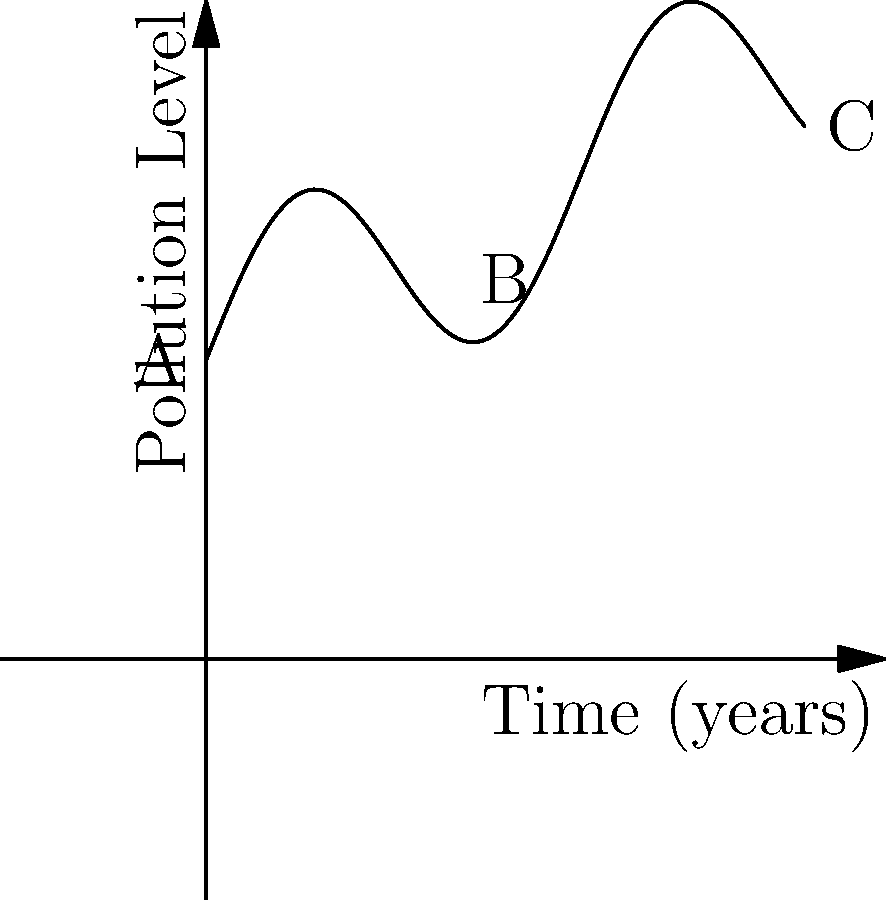The curve above represents the pollution levels in a major industrial area over a 10-year period. If $P(t)$ denotes the pollution level at time $t$, and $P(t) = 5 + 2\sin(t) + 0.5t$, calculate the rate of change in pollution levels at $t=5$ years. How does this information assist in evaluating the effectiveness of current environmental regulations? To solve this problem, we need to follow these steps:

1) The rate of change in pollution levels at any given time is represented by the derivative of $P(t)$ with respect to $t$.

2) Given: $P(t) = 5 + 2\sin(t) + 0.5t$

3) To find $\frac{dP}{dt}$, we differentiate each term:
   $\frac{d}{dt}(5) = 0$
   $\frac{d}{dt}(2\sin(t)) = 2\cos(t)$
   $\frac{d}{dt}(0.5t) = 0.5$

4) Therefore, $\frac{dP}{dt} = 2\cos(t) + 0.5$

5) At $t=5$:
   $\frac{dP}{dt}|_{t=5} = 2\cos(5) + 0.5 \approx 0.7145$

6) Interpretation: The positive value indicates that pollution levels are increasing at $t=5$ years, at a rate of approximately 0.7145 units per year.

7) This information assists in evaluating the effectiveness of current environmental regulations by:
   a) Indicating whether pollution levels are increasing or decreasing at a specific point in time.
   b) Quantifying the rate of change, which can be compared to acceptable standards or targets.
   c) Helping identify trends and patterns in pollution levels over time.
   d) Providing a basis for adjusting or implementing new regulations to address rising pollution levels.
Answer: $\frac{dP}{dt}|_{t=5} \approx 0.7145$ units/year 